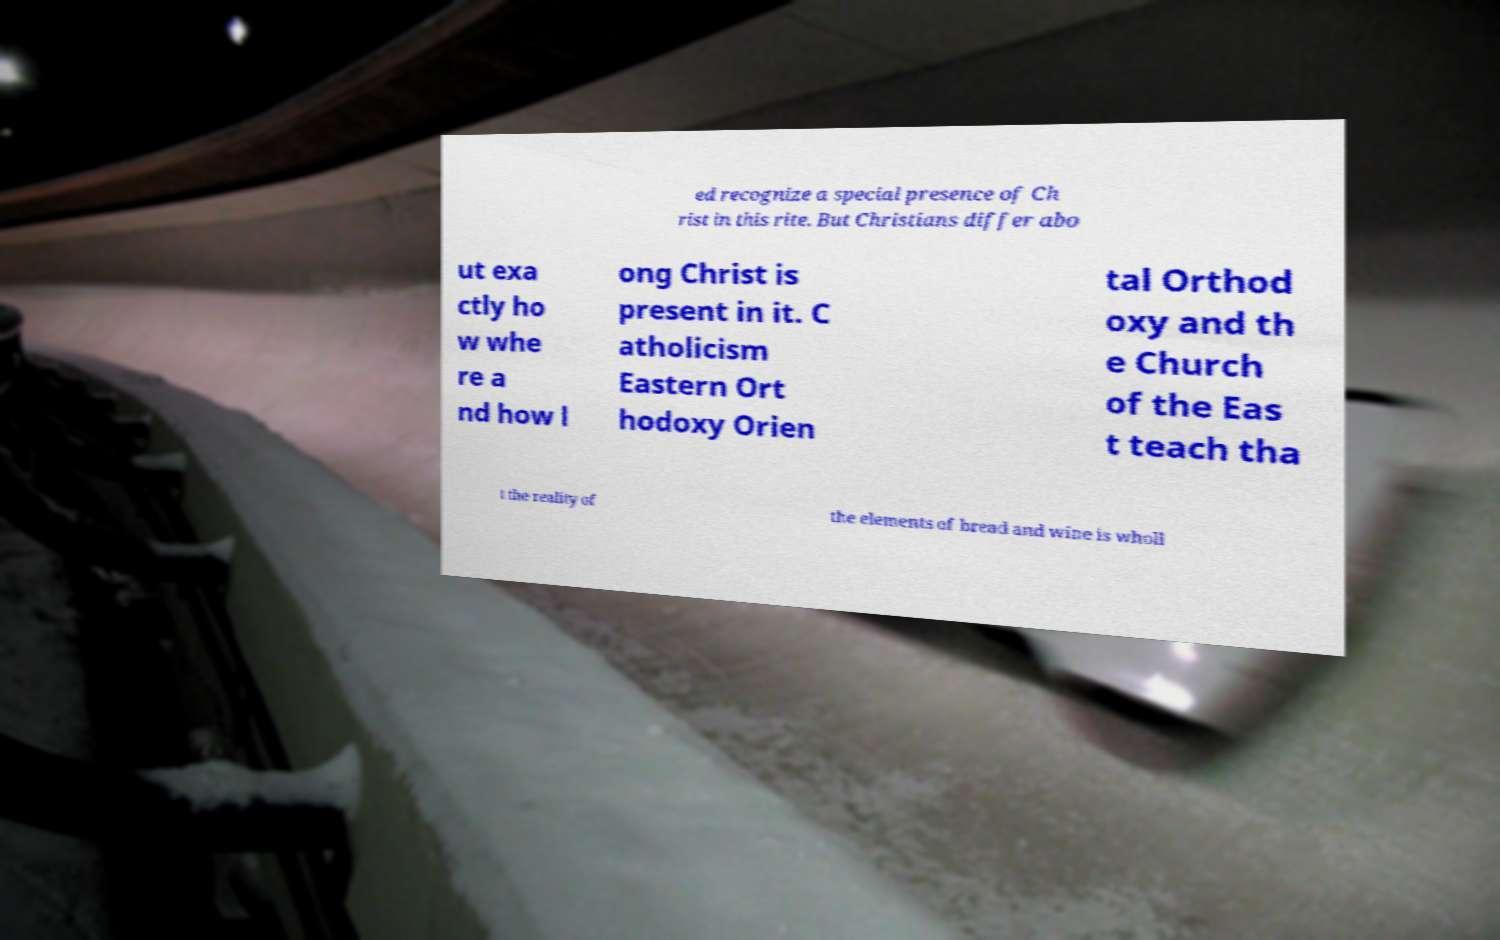Please identify and transcribe the text found in this image. ed recognize a special presence of Ch rist in this rite. But Christians differ abo ut exa ctly ho w whe re a nd how l ong Christ is present in it. C atholicism Eastern Ort hodoxy Orien tal Orthod oxy and th e Church of the Eas t teach tha t the reality of the elements of bread and wine is wholl 